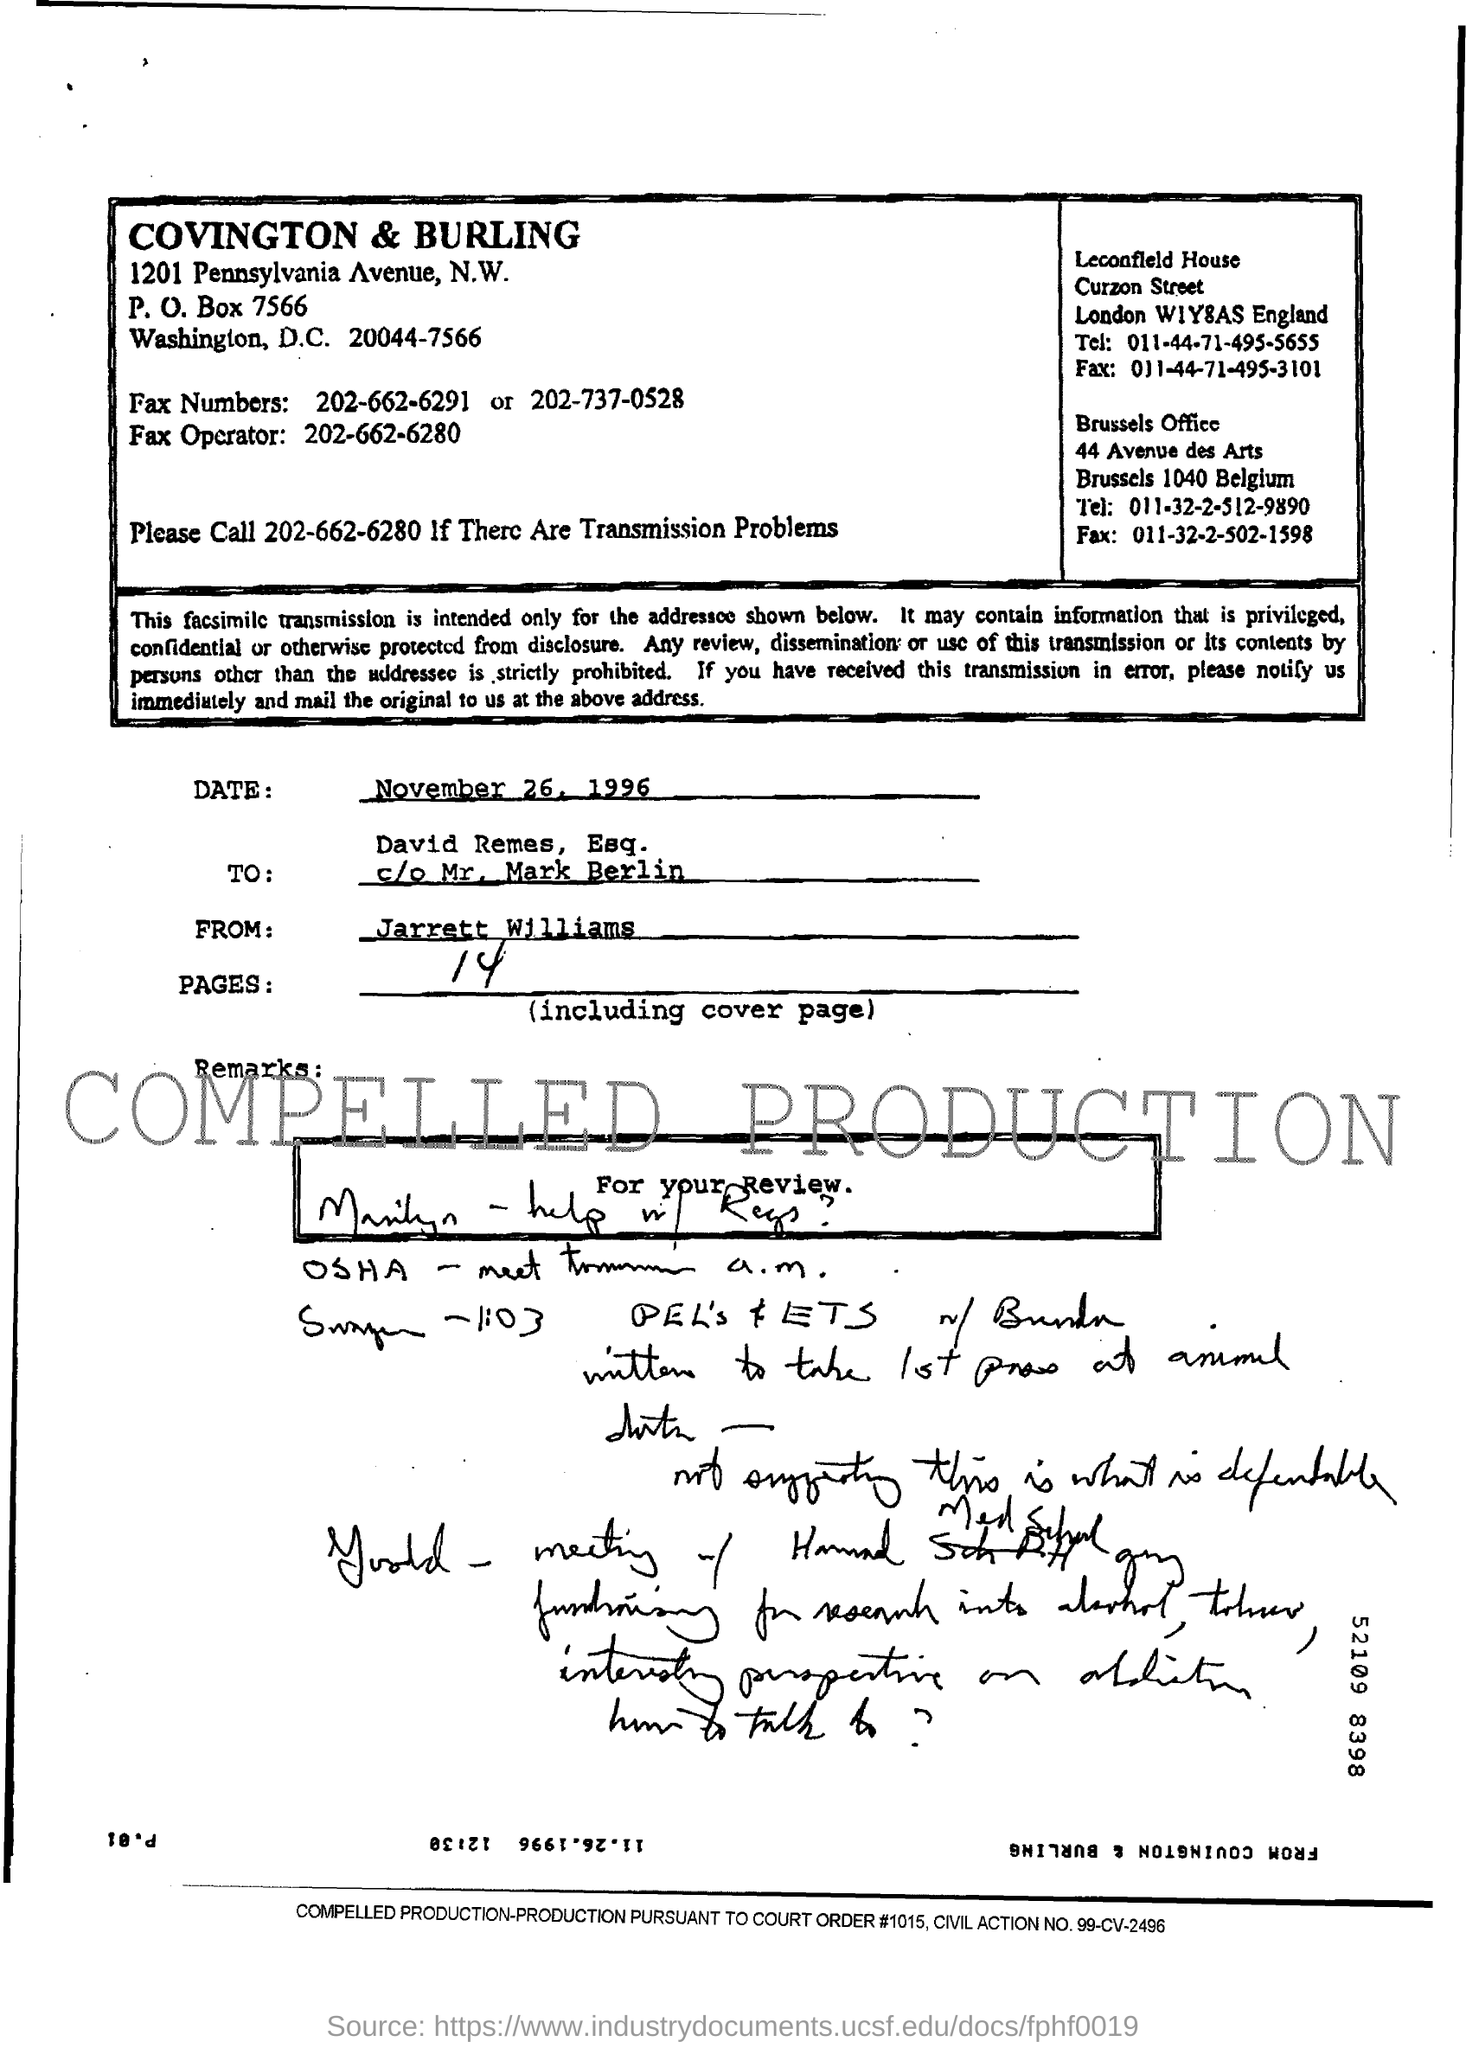Draw attention to some important aspects in this diagram. The sender of the fax is identified as Jarrett Williams. The fax is intended for David Remes. The date of the fax transmission was November 26, 1996. There are 14 pages in the fax including the cover page. The fax operator number mentioned in the document is 202-662-6280. 